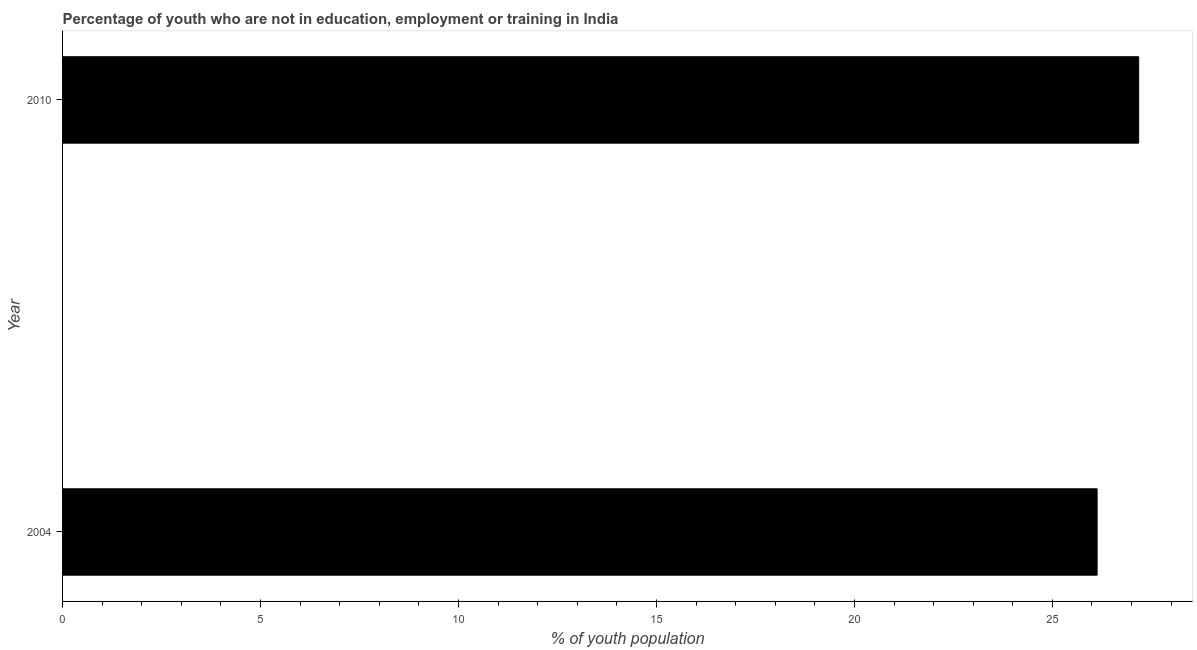Does the graph contain any zero values?
Offer a terse response. No. What is the title of the graph?
Offer a very short reply. Percentage of youth who are not in education, employment or training in India. What is the label or title of the X-axis?
Ensure brevity in your answer.  % of youth population. What is the unemployed youth population in 2004?
Your answer should be very brief. 26.13. Across all years, what is the maximum unemployed youth population?
Ensure brevity in your answer.  27.18. Across all years, what is the minimum unemployed youth population?
Keep it short and to the point. 26.13. In which year was the unemployed youth population minimum?
Your answer should be very brief. 2004. What is the sum of the unemployed youth population?
Ensure brevity in your answer.  53.31. What is the difference between the unemployed youth population in 2004 and 2010?
Offer a very short reply. -1.05. What is the average unemployed youth population per year?
Offer a terse response. 26.66. What is the median unemployed youth population?
Offer a very short reply. 26.65. Do a majority of the years between 2010 and 2004 (inclusive) have unemployed youth population greater than 9 %?
Provide a succinct answer. No. What is the ratio of the unemployed youth population in 2004 to that in 2010?
Provide a short and direct response. 0.96. Is the unemployed youth population in 2004 less than that in 2010?
Offer a terse response. Yes. How many bars are there?
Make the answer very short. 2. How many years are there in the graph?
Your answer should be compact. 2. What is the difference between two consecutive major ticks on the X-axis?
Your answer should be compact. 5. What is the % of youth population in 2004?
Your answer should be compact. 26.13. What is the % of youth population of 2010?
Offer a terse response. 27.18. What is the difference between the % of youth population in 2004 and 2010?
Provide a succinct answer. -1.05. What is the ratio of the % of youth population in 2004 to that in 2010?
Give a very brief answer. 0.96. 